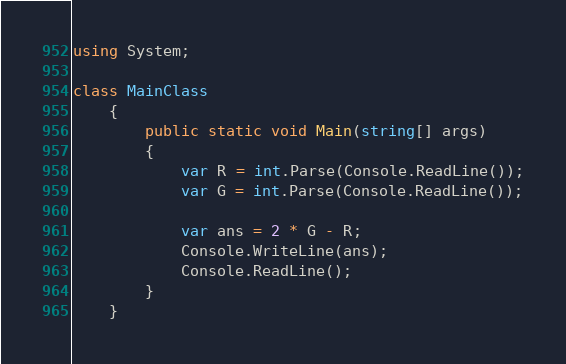Convert code to text. <code><loc_0><loc_0><loc_500><loc_500><_C#_>using System;

class MainClass
    {
        public static void Main(string[] args)
        {
            var R = int.Parse(Console.ReadLine());
            var G = int.Parse(Console.ReadLine());

            var ans = 2 * G - R;
            Console.WriteLine(ans);
            Console.ReadLine();
        }
    }</code> 